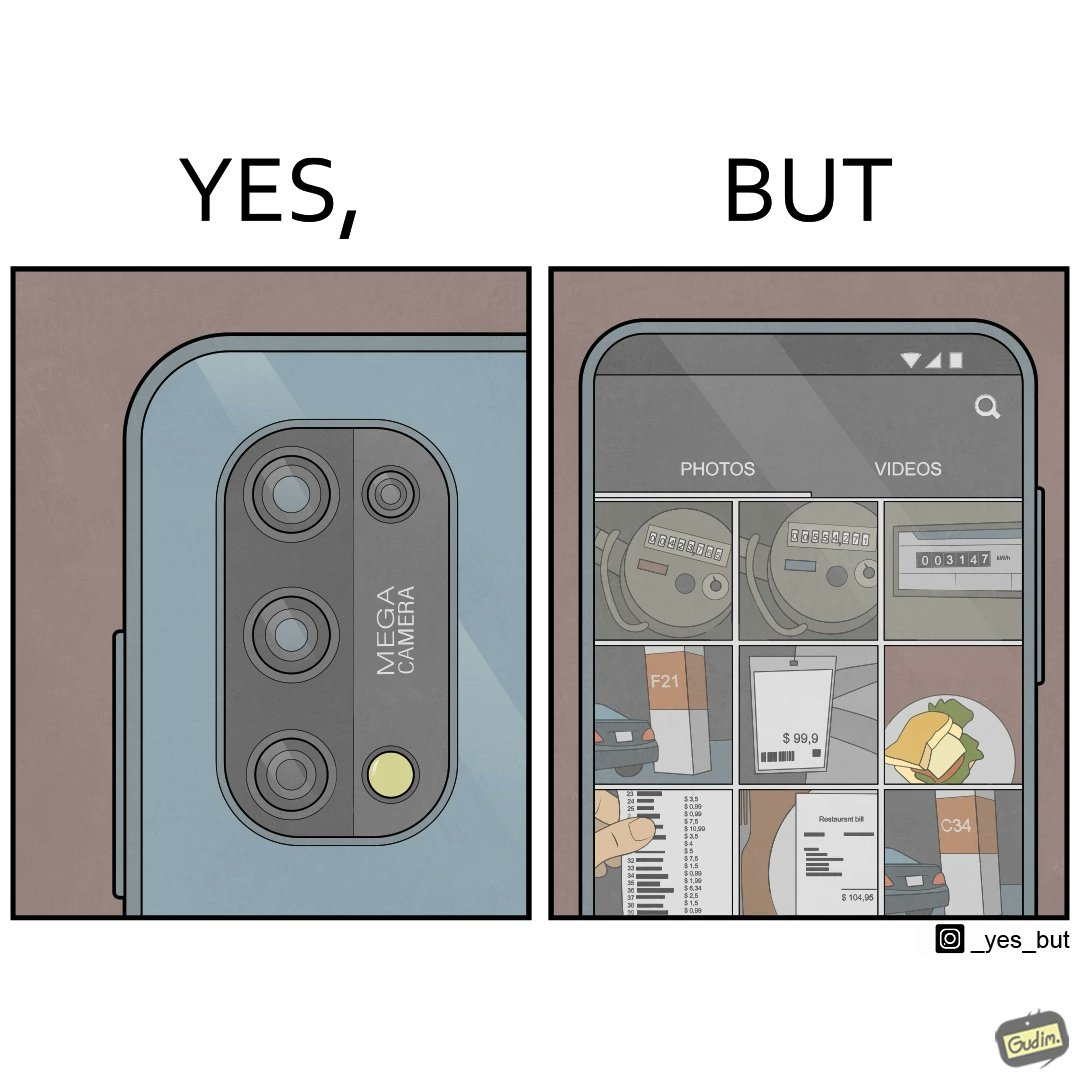Provide a description of this image. The irony here is that people buy phones with flashy camera systems just to click pictures of random and insignificant things. 